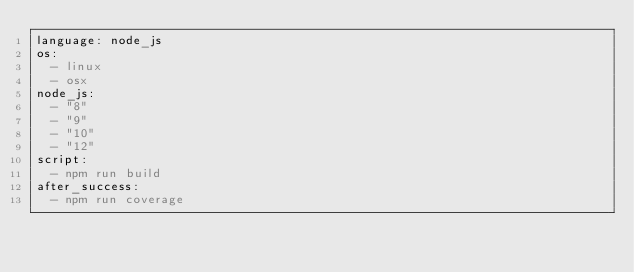<code> <loc_0><loc_0><loc_500><loc_500><_YAML_>language: node_js
os:
  - linux
  - osx
node_js:
  - "8"
  - "9"
  - "10"
  - "12"
script:
  - npm run build
after_success:
  - npm run coverage
</code> 